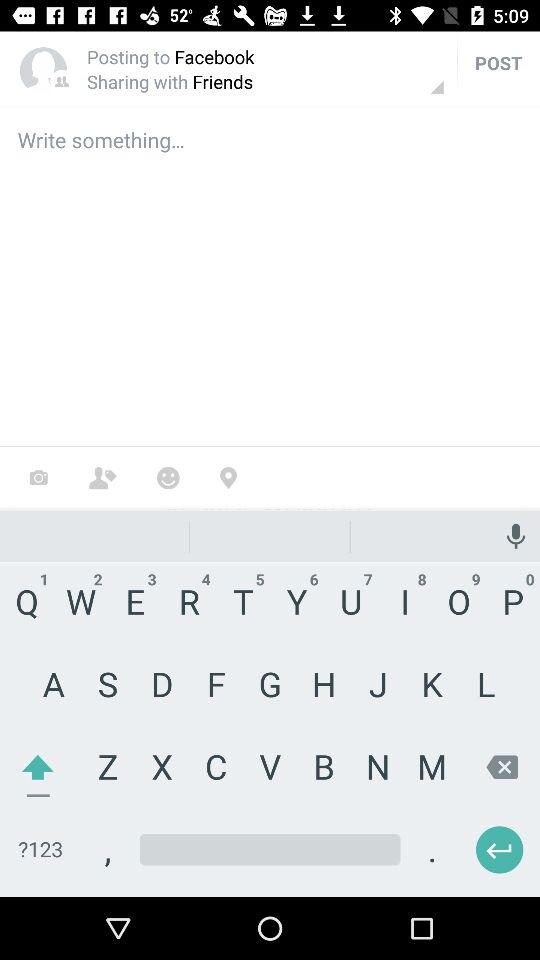What is the name of the application that can be used to log in? The name of the application that can be used to log in is "Facebook". 